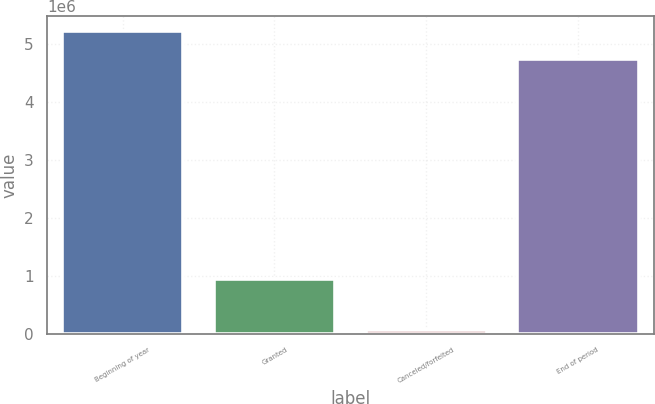Convert chart to OTSL. <chart><loc_0><loc_0><loc_500><loc_500><bar_chart><fcel>Beginning of year<fcel>Granted<fcel>Canceled/forfeited<fcel>End of period<nl><fcel>5.22532e+06<fcel>949200<fcel>69800<fcel>4.747e+06<nl></chart> 